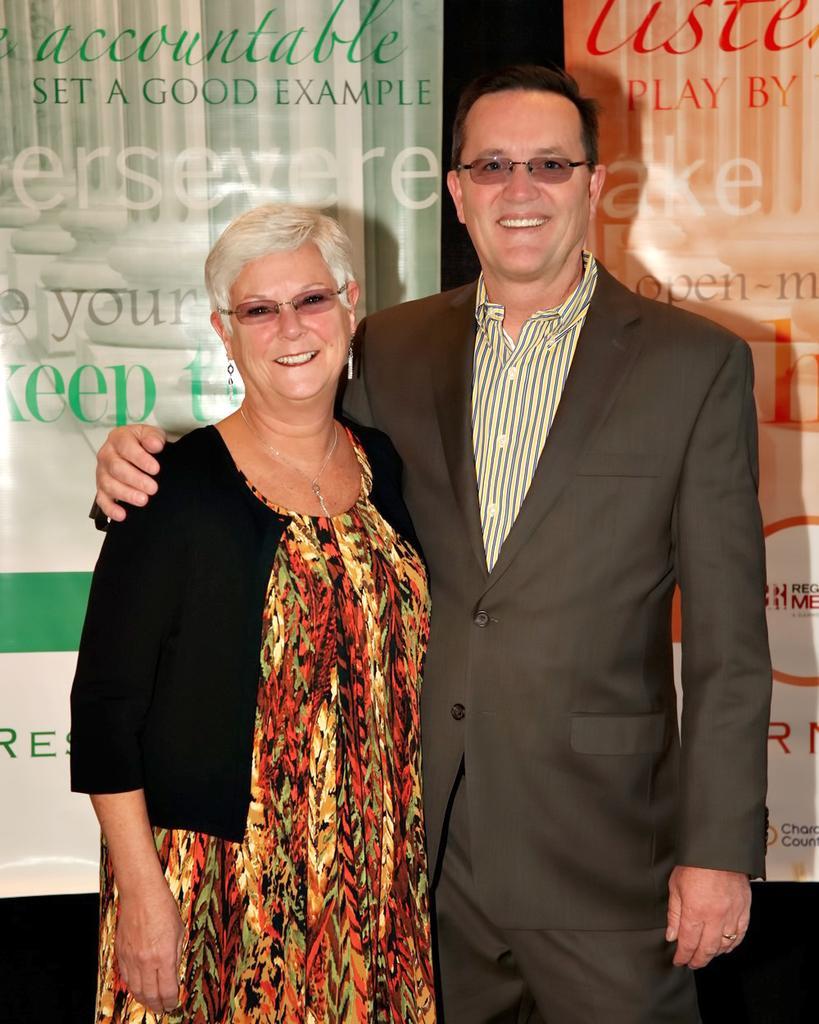Please provide a concise description of this image. In this image we can see two people are standing and backside of these two people there are two banners with text. 